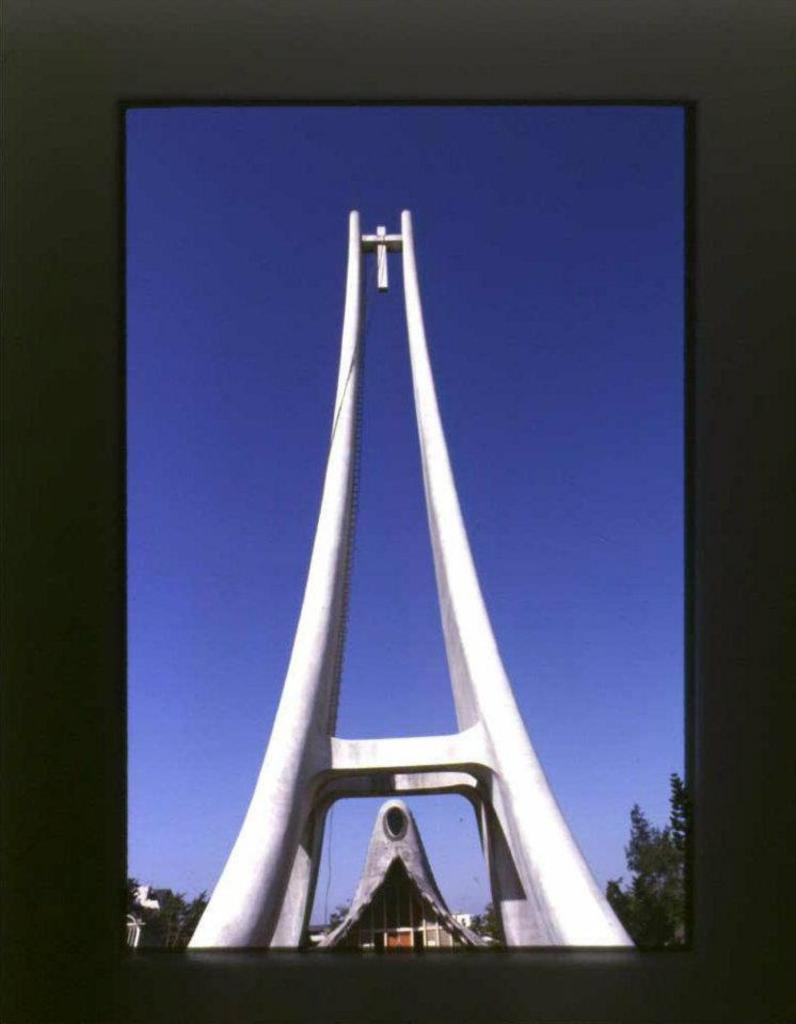What is the main subject of the image? There is a white object in the image. What can be seen at the bottom of the image? Trees and buildings are visible at the bottom of the image. What is visible in the background of the image? The sky is visible in the background of the image. How many geese are visible in the image? There are no geese present in the image. What sense is being stimulated by the white object in the image? The provided facts do not mention any sensory stimulation related to the white object, so it is not possible to answer this question. 